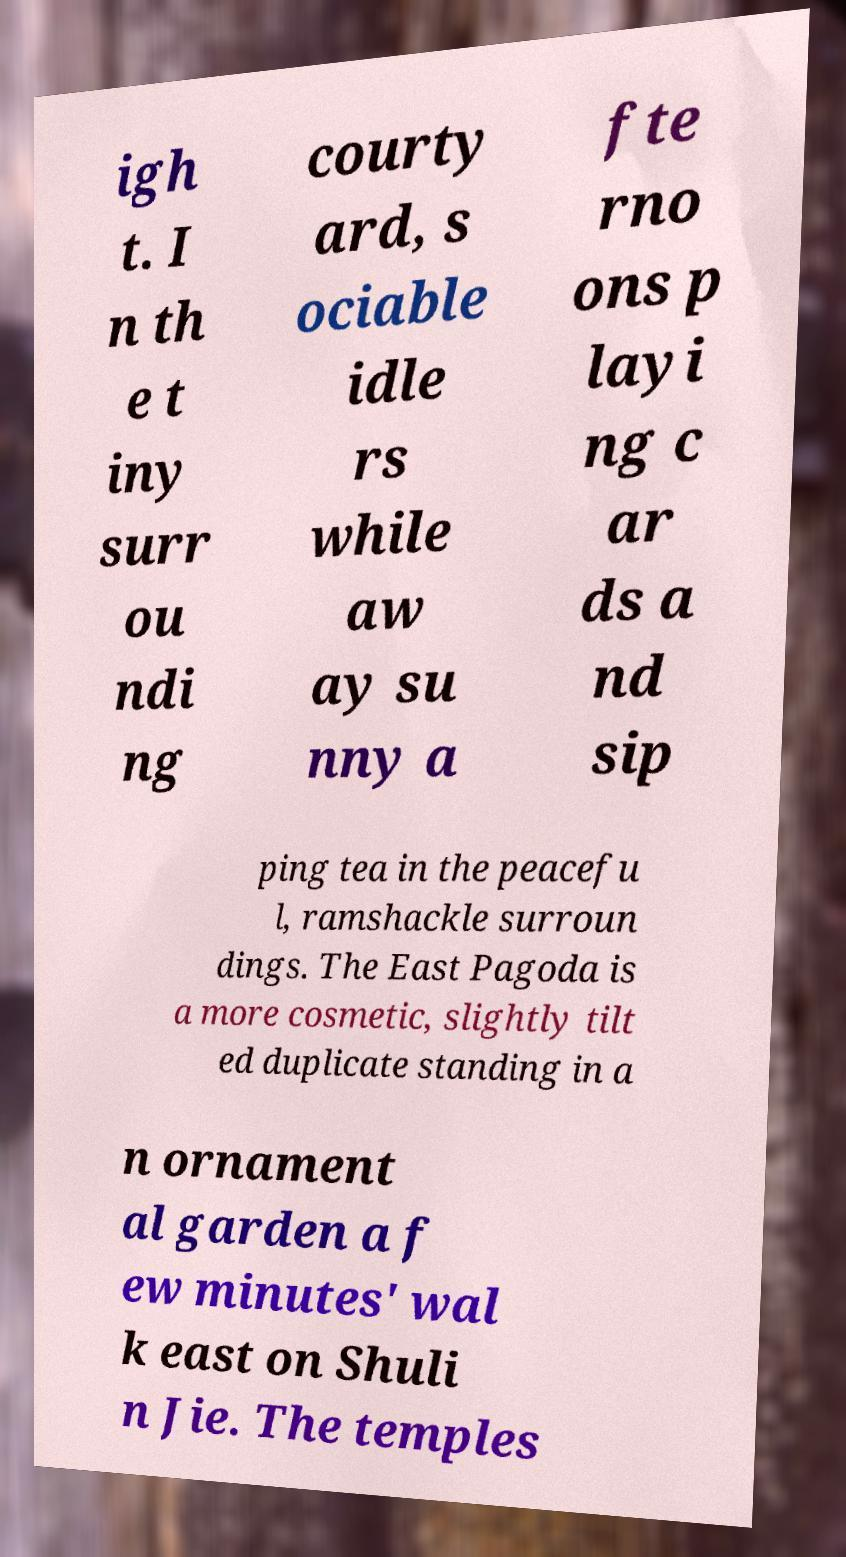What messages or text are displayed in this image? I need them in a readable, typed format. igh t. I n th e t iny surr ou ndi ng courty ard, s ociable idle rs while aw ay su nny a fte rno ons p layi ng c ar ds a nd sip ping tea in the peacefu l, ramshackle surroun dings. The East Pagoda is a more cosmetic, slightly tilt ed duplicate standing in a n ornament al garden a f ew minutes' wal k east on Shuli n Jie. The temples 